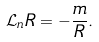<formula> <loc_0><loc_0><loc_500><loc_500>\mathcal { L } _ { n } R = - \frac { m } { R } .</formula> 